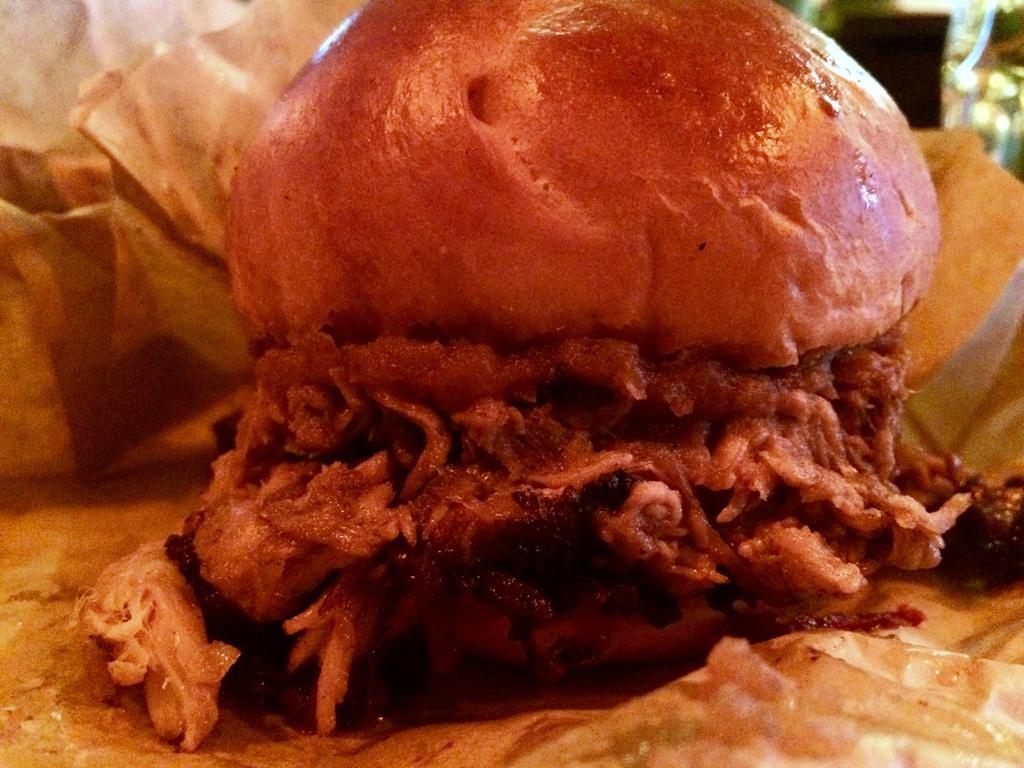Could you give a brief overview of what you see in this image? In this picture I can see in the middle there is the food. 